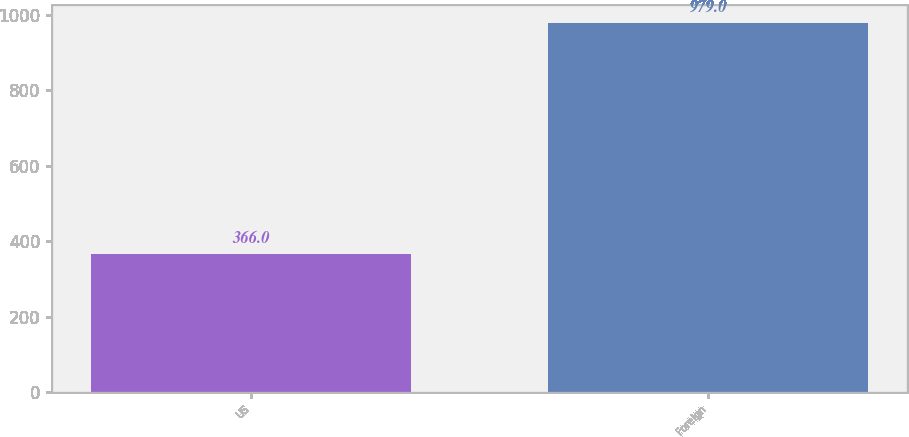Convert chart to OTSL. <chart><loc_0><loc_0><loc_500><loc_500><bar_chart><fcel>US<fcel>Foreign<nl><fcel>366<fcel>979<nl></chart> 